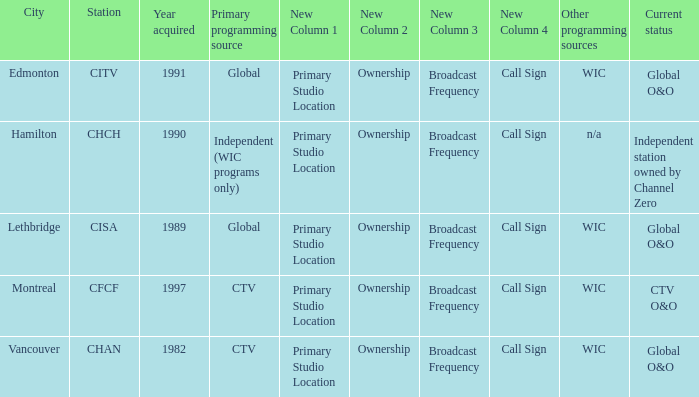Which station is located in edmonton CITV. 